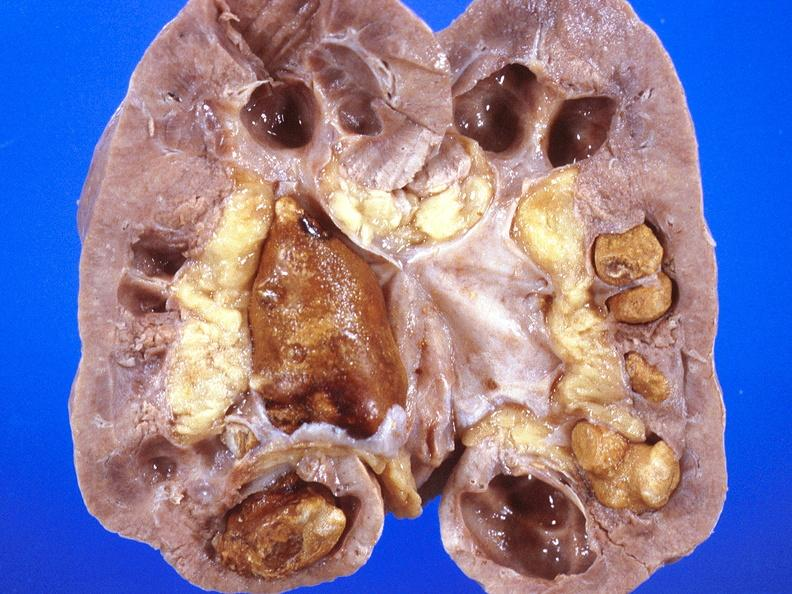does this image show renal pelvis, staghorn calculi?
Answer the question using a single word or phrase. Yes 